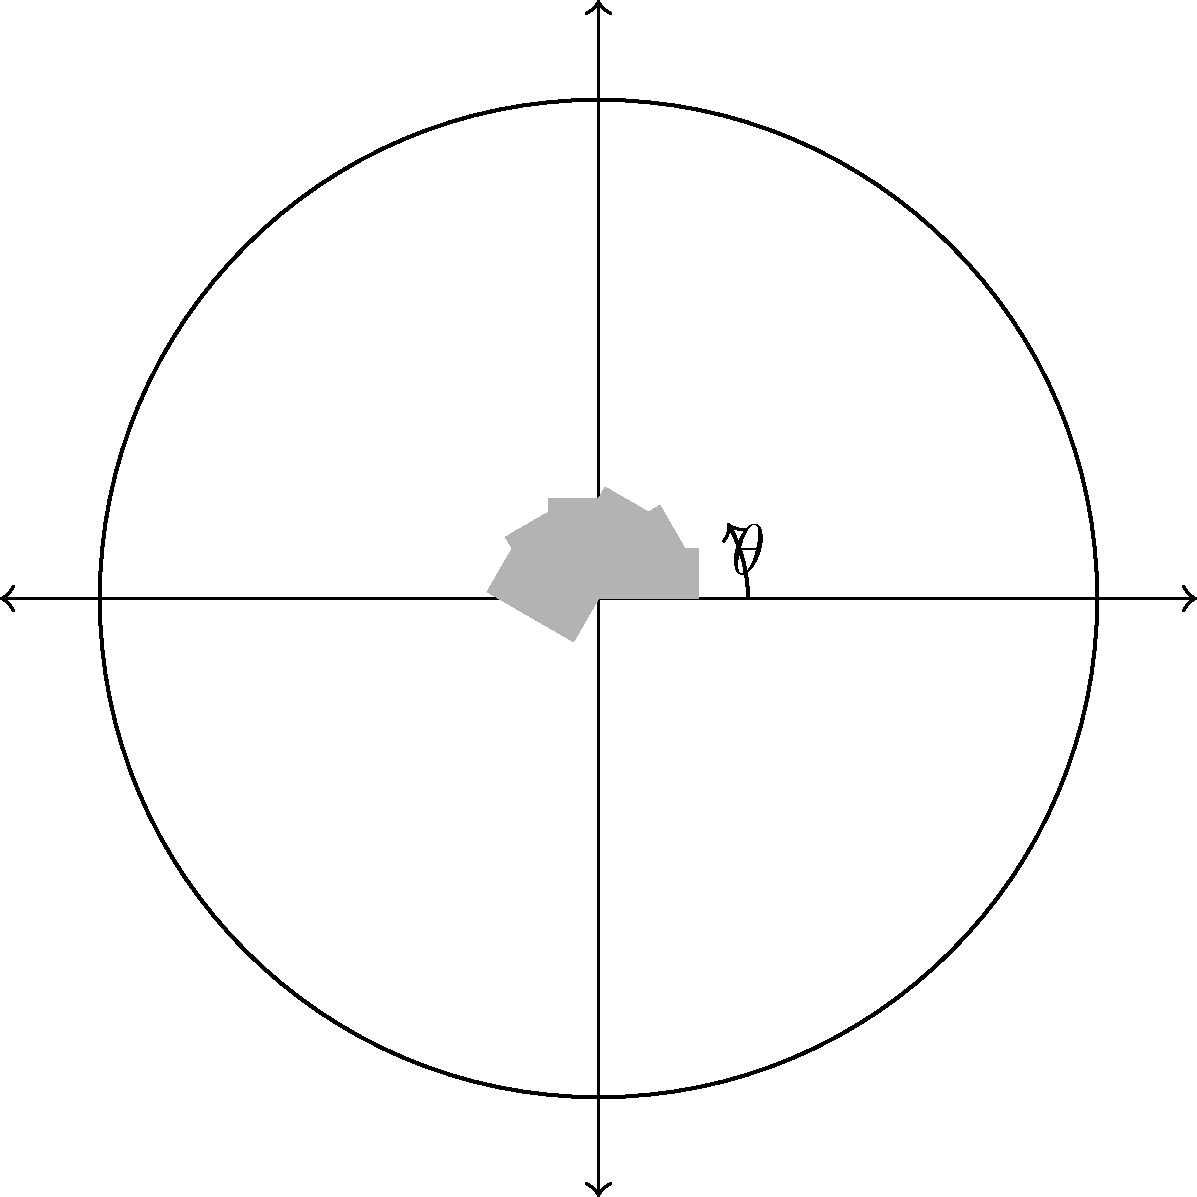In a circular parking lot with a diameter of 20 meters, you need to maximize the number of cars that can be parked. Each car is 4 meters long and 2 meters wide. What is the optimal angle $\theta$ (in degrees) between adjacent cars to fit the maximum number of vehicles? To solve this problem, let's follow these steps:

1) The circumference of the parking lot is $C = \pi d = \pi \cdot 20 = 20\pi$ meters.

2) Each car occupies an arc length along the circumference. This arc length is equal to the width of the car when parked at an angle.

3) The effective width of a car when parked at an angle $\theta$ is:
   $w = 2 \sin(\theta) + 4 \cos(\theta)$

4) The number of cars that can fit is:
   $n = \frac{20\pi}{2 \sin(\theta) + 4 \cos(\theta)}$

5) To maximize $n$, we need to minimize the denominator. We can do this by differentiating with respect to $\theta$ and setting it to zero:

   $\frac{d}{d\theta}(2 \sin(\theta) + 4 \cos(\theta)) = 2 \cos(\theta) - 4 \sin(\theta) = 0$

6) Solving this equation:
   $\tan(\theta) = \frac{1}{2}$

7) Taking the inverse tangent:
   $\theta = \arctan(\frac{1}{2}) \approx 26.57°$

8) To verify this is a minimum (maximum number of cars), we can check the second derivative is positive at this point.

9) Rounding to the nearest degree for practical application in a real parking scenario:
   $\theta \approx 27°$
Answer: 27° 